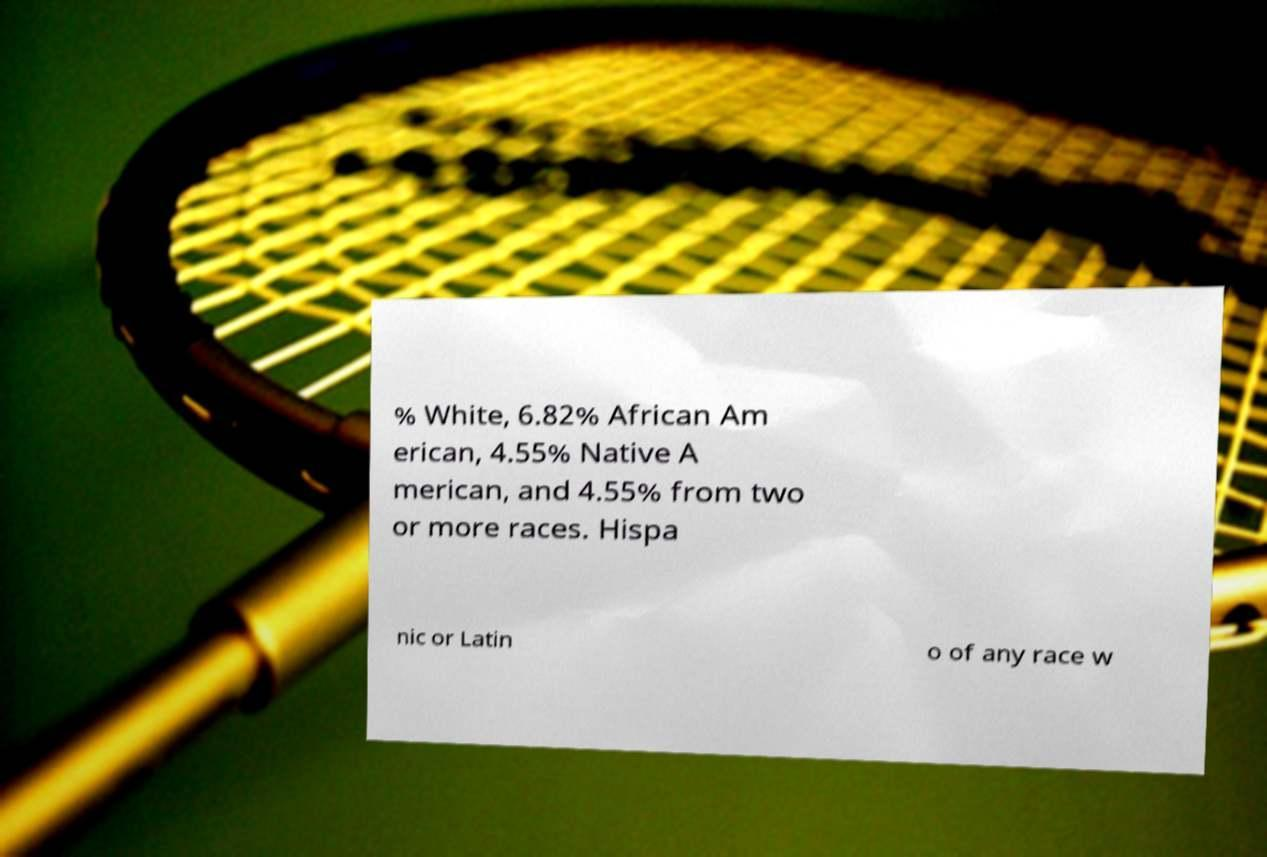For documentation purposes, I need the text within this image transcribed. Could you provide that? % White, 6.82% African Am erican, 4.55% Native A merican, and 4.55% from two or more races. Hispa nic or Latin o of any race w 